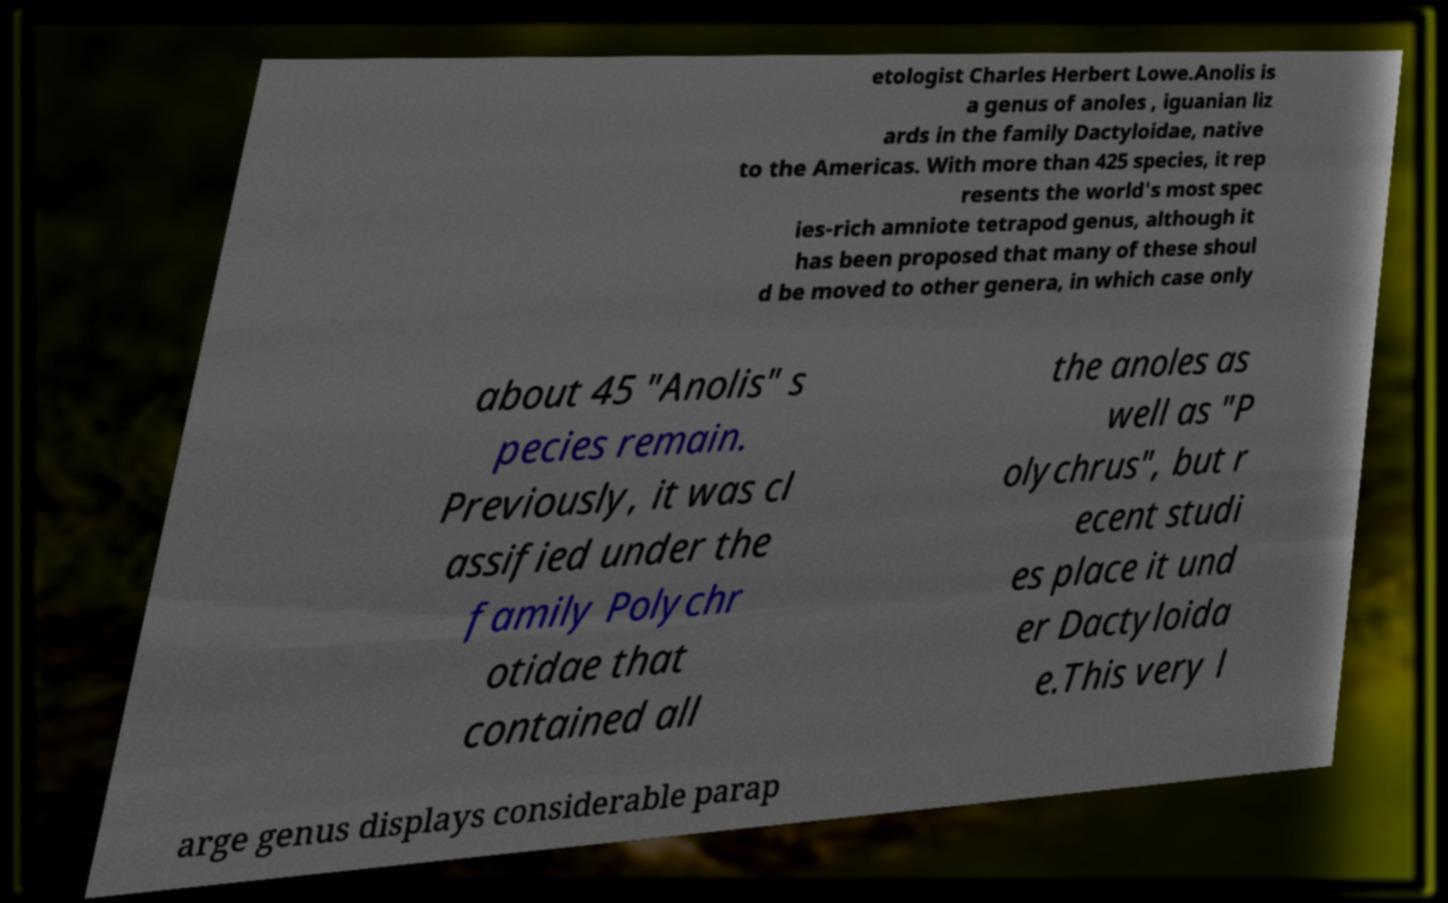Could you assist in decoding the text presented in this image and type it out clearly? etologist Charles Herbert Lowe.Anolis is a genus of anoles , iguanian liz ards in the family Dactyloidae, native to the Americas. With more than 425 species, it rep resents the world's most spec ies-rich amniote tetrapod genus, although it has been proposed that many of these shoul d be moved to other genera, in which case only about 45 "Anolis" s pecies remain. Previously, it was cl assified under the family Polychr otidae that contained all the anoles as well as "P olychrus", but r ecent studi es place it und er Dactyloida e.This very l arge genus displays considerable parap 